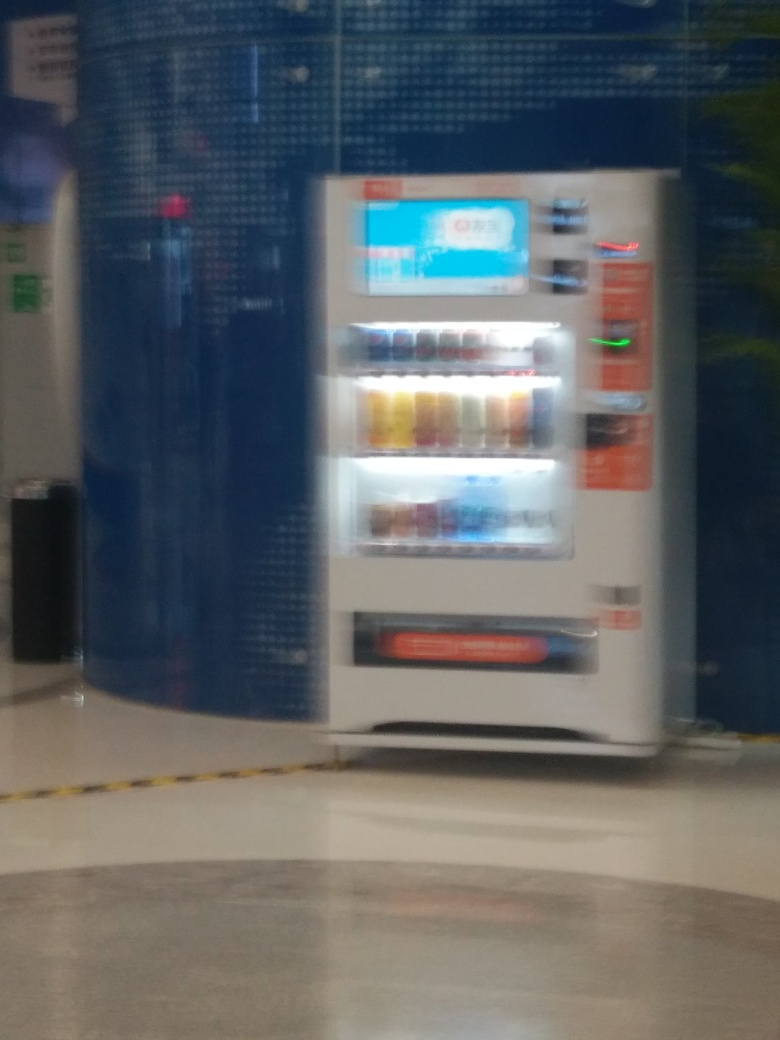What kind of items can you see in the vending machine? The vending machine contains an assortment of beverages, including what appear to be bottled water, sodas, and possibly some juice options. The exact brands and types are unclear due to the blurriness of the image. 